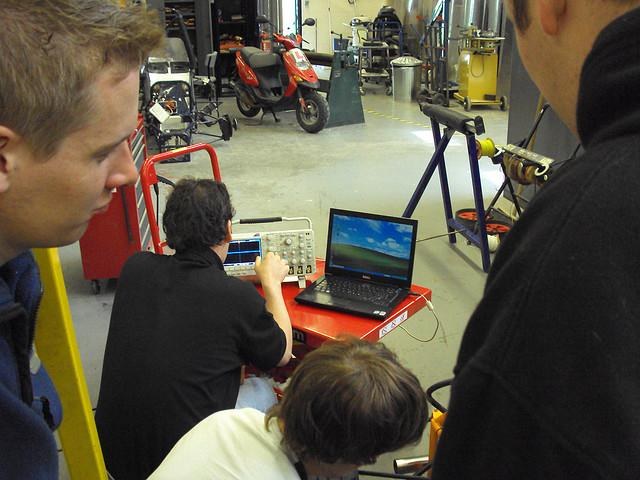What is the man using to control the grey device? Please explain your reasoning. laptop. The grey device is plugged in to the laptop. 